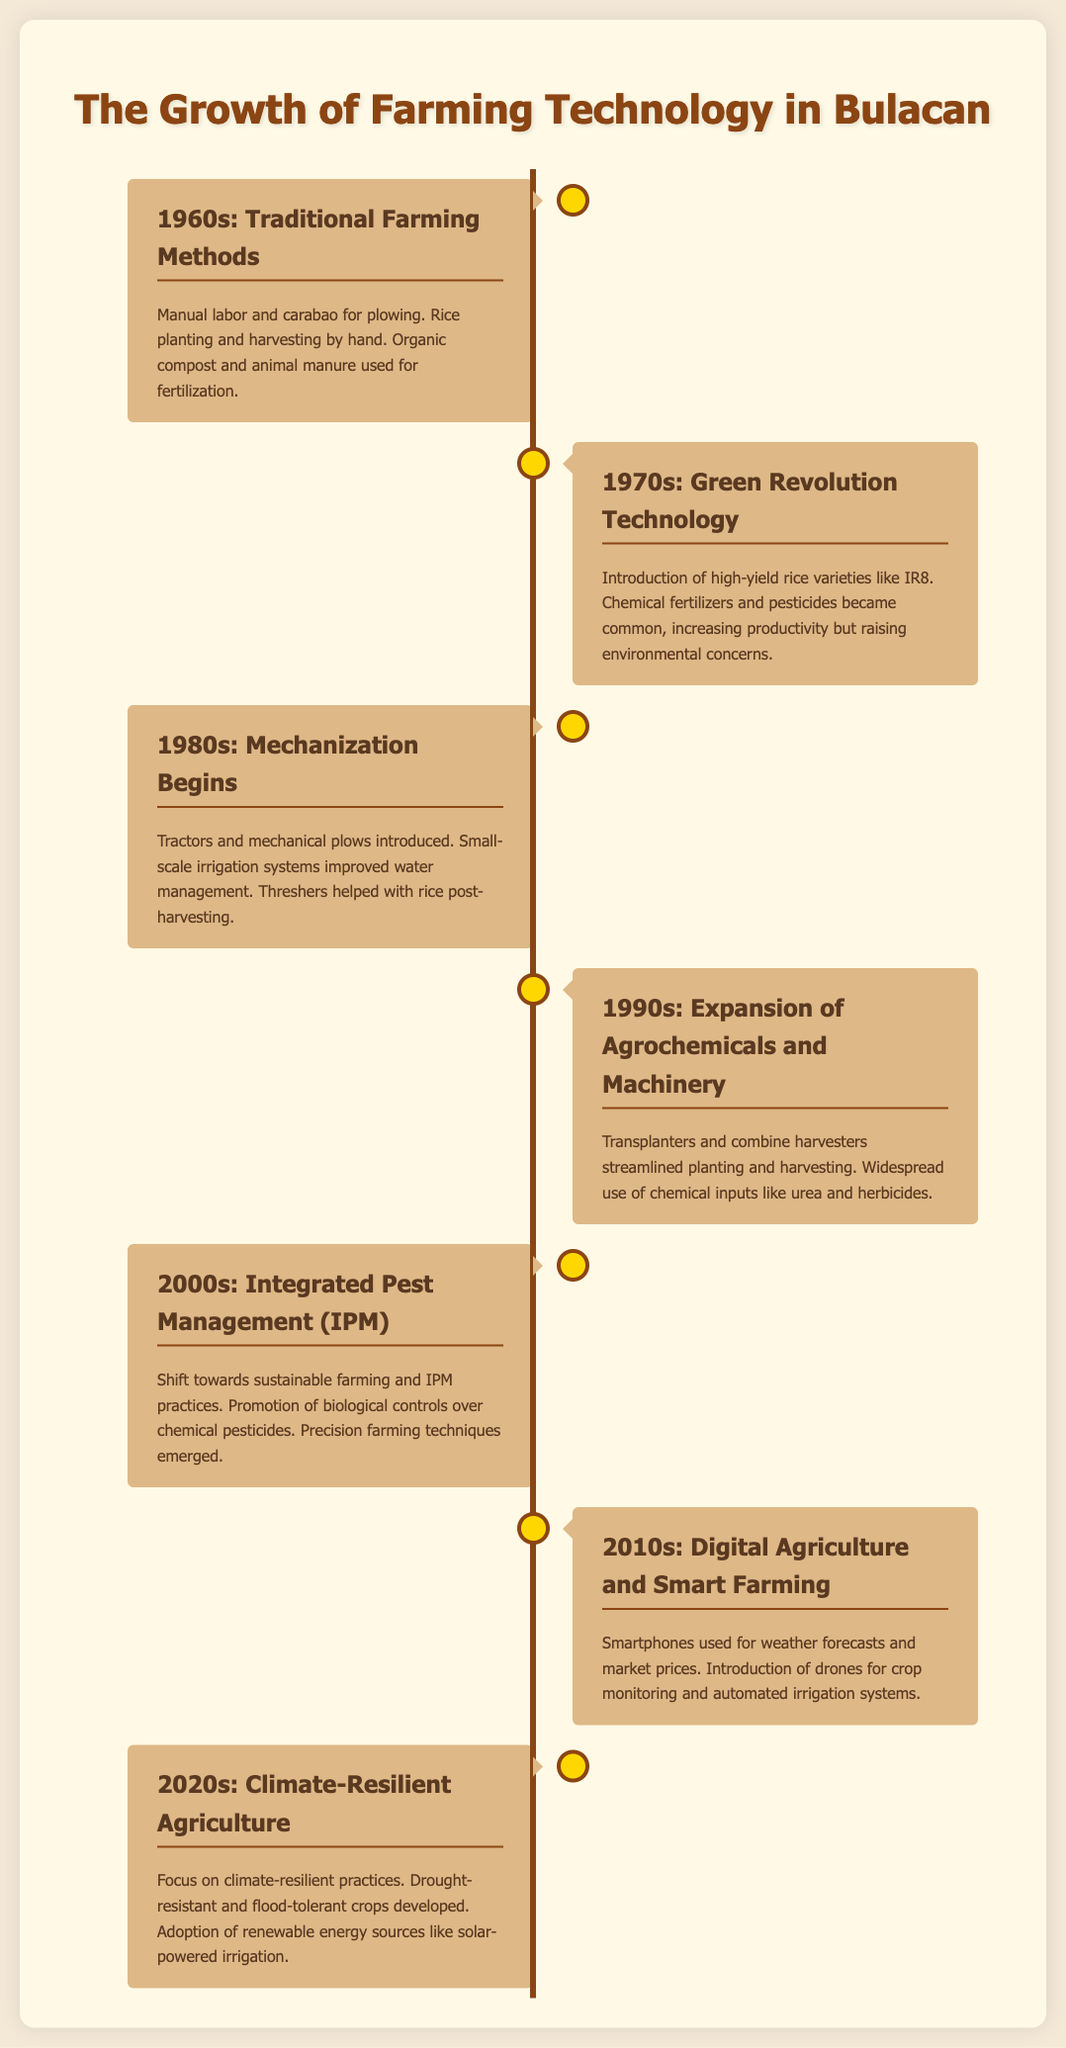What farming method was mostly used in the 1960s? The 1960s primarily featured manual labor and the use of carabaos for plowing.
Answer: Manual labor and carabao What significant agricultural development occurred in the 1970s? The Green Revolution introduced high-yield rice varieties like IR8.
Answer: High-yield rice varieties What machinery was introduced in the 1980s? The 1980s saw the introduction of tractors and mechanical plows.
Answer: Tractors and mechanical plows Which farming practice emerged in the 2000s? The focus shifted towards Integrated Pest Management (IPM) during the 2000s.
Answer: Integrated Pest Management (IPM) What technology became prevalent in the 2010s? The 2010s featured digital agriculture and smart farming technologies.
Answer: Digital agriculture and smart farming What type of crops are emphasized in the 2020s? The 2020s emphasize drought-resistant and flood-tolerant crops.
Answer: Drought-resistant and flood-tolerant crops What environmental concerns arose in the 1970s? The use of chemical fertilizers and pesticides raised environmental concerns.
Answer: Environmental concerns What irrigation improvement was noted in the 1980s? The 1980s saw small-scale irrigation systems improve water management.
Answer: Small-scale irrigation systems Which decade introduced automated irrigation systems? The 2010s introduced automated irrigation systems as part of smart farming.
Answer: 2010s 